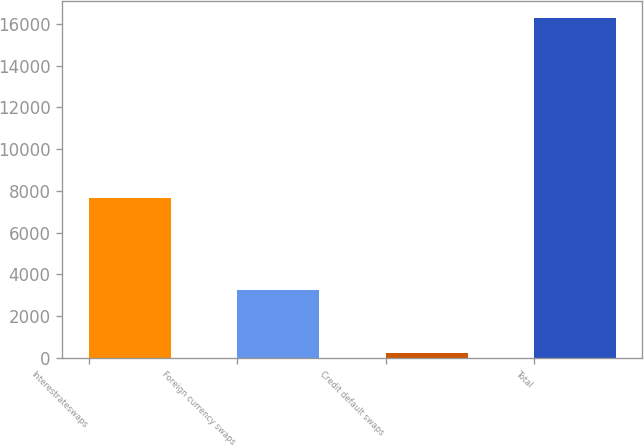Convert chart to OTSL. <chart><loc_0><loc_0><loc_500><loc_500><bar_chart><fcel>Interestrateswaps<fcel>Foreign currency swaps<fcel>Credit default swaps<fcel>Total<nl><fcel>7644<fcel>3265<fcel>249<fcel>16278<nl></chart> 